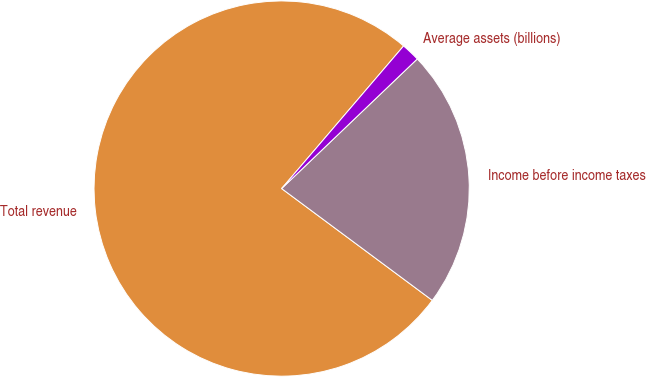<chart> <loc_0><loc_0><loc_500><loc_500><pie_chart><fcel>Total revenue<fcel>Income before income taxes<fcel>Average assets (billions)<nl><fcel>76.1%<fcel>22.3%<fcel>1.6%<nl></chart> 